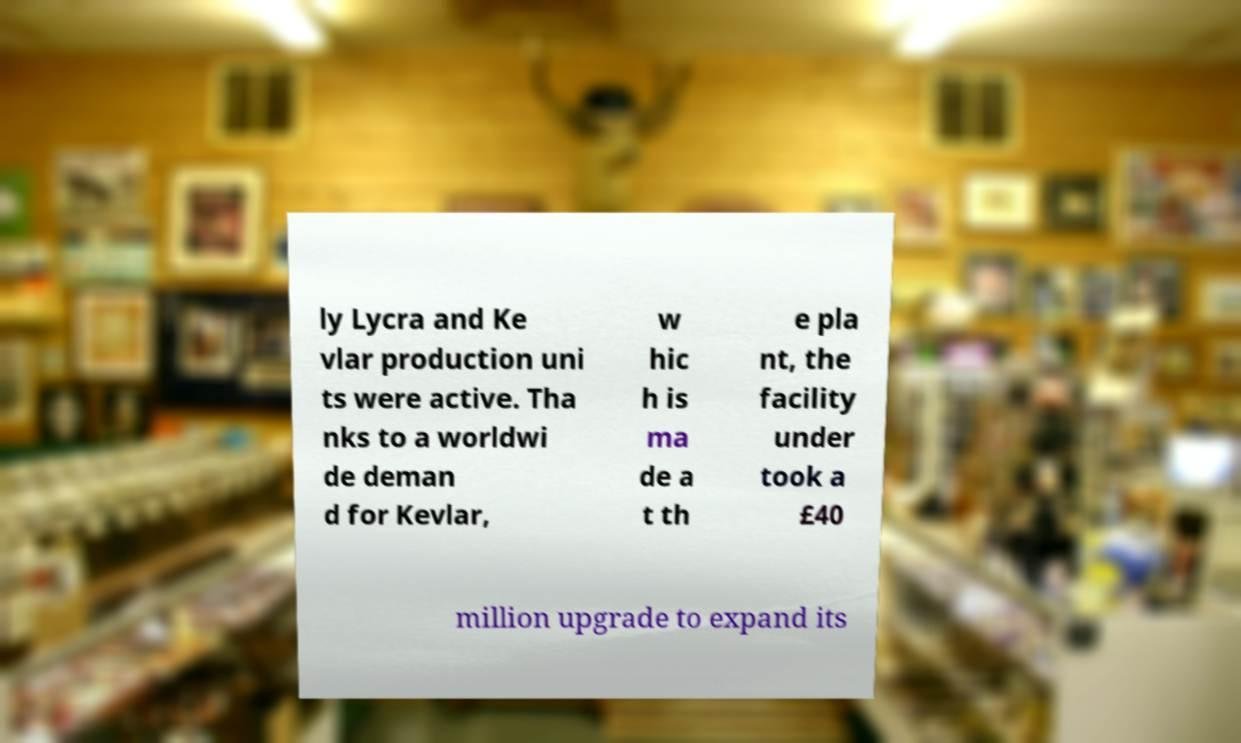What messages or text are displayed in this image? I need them in a readable, typed format. ly Lycra and Ke vlar production uni ts were active. Tha nks to a worldwi de deman d for Kevlar, w hic h is ma de a t th e pla nt, the facility under took a £40 million upgrade to expand its 